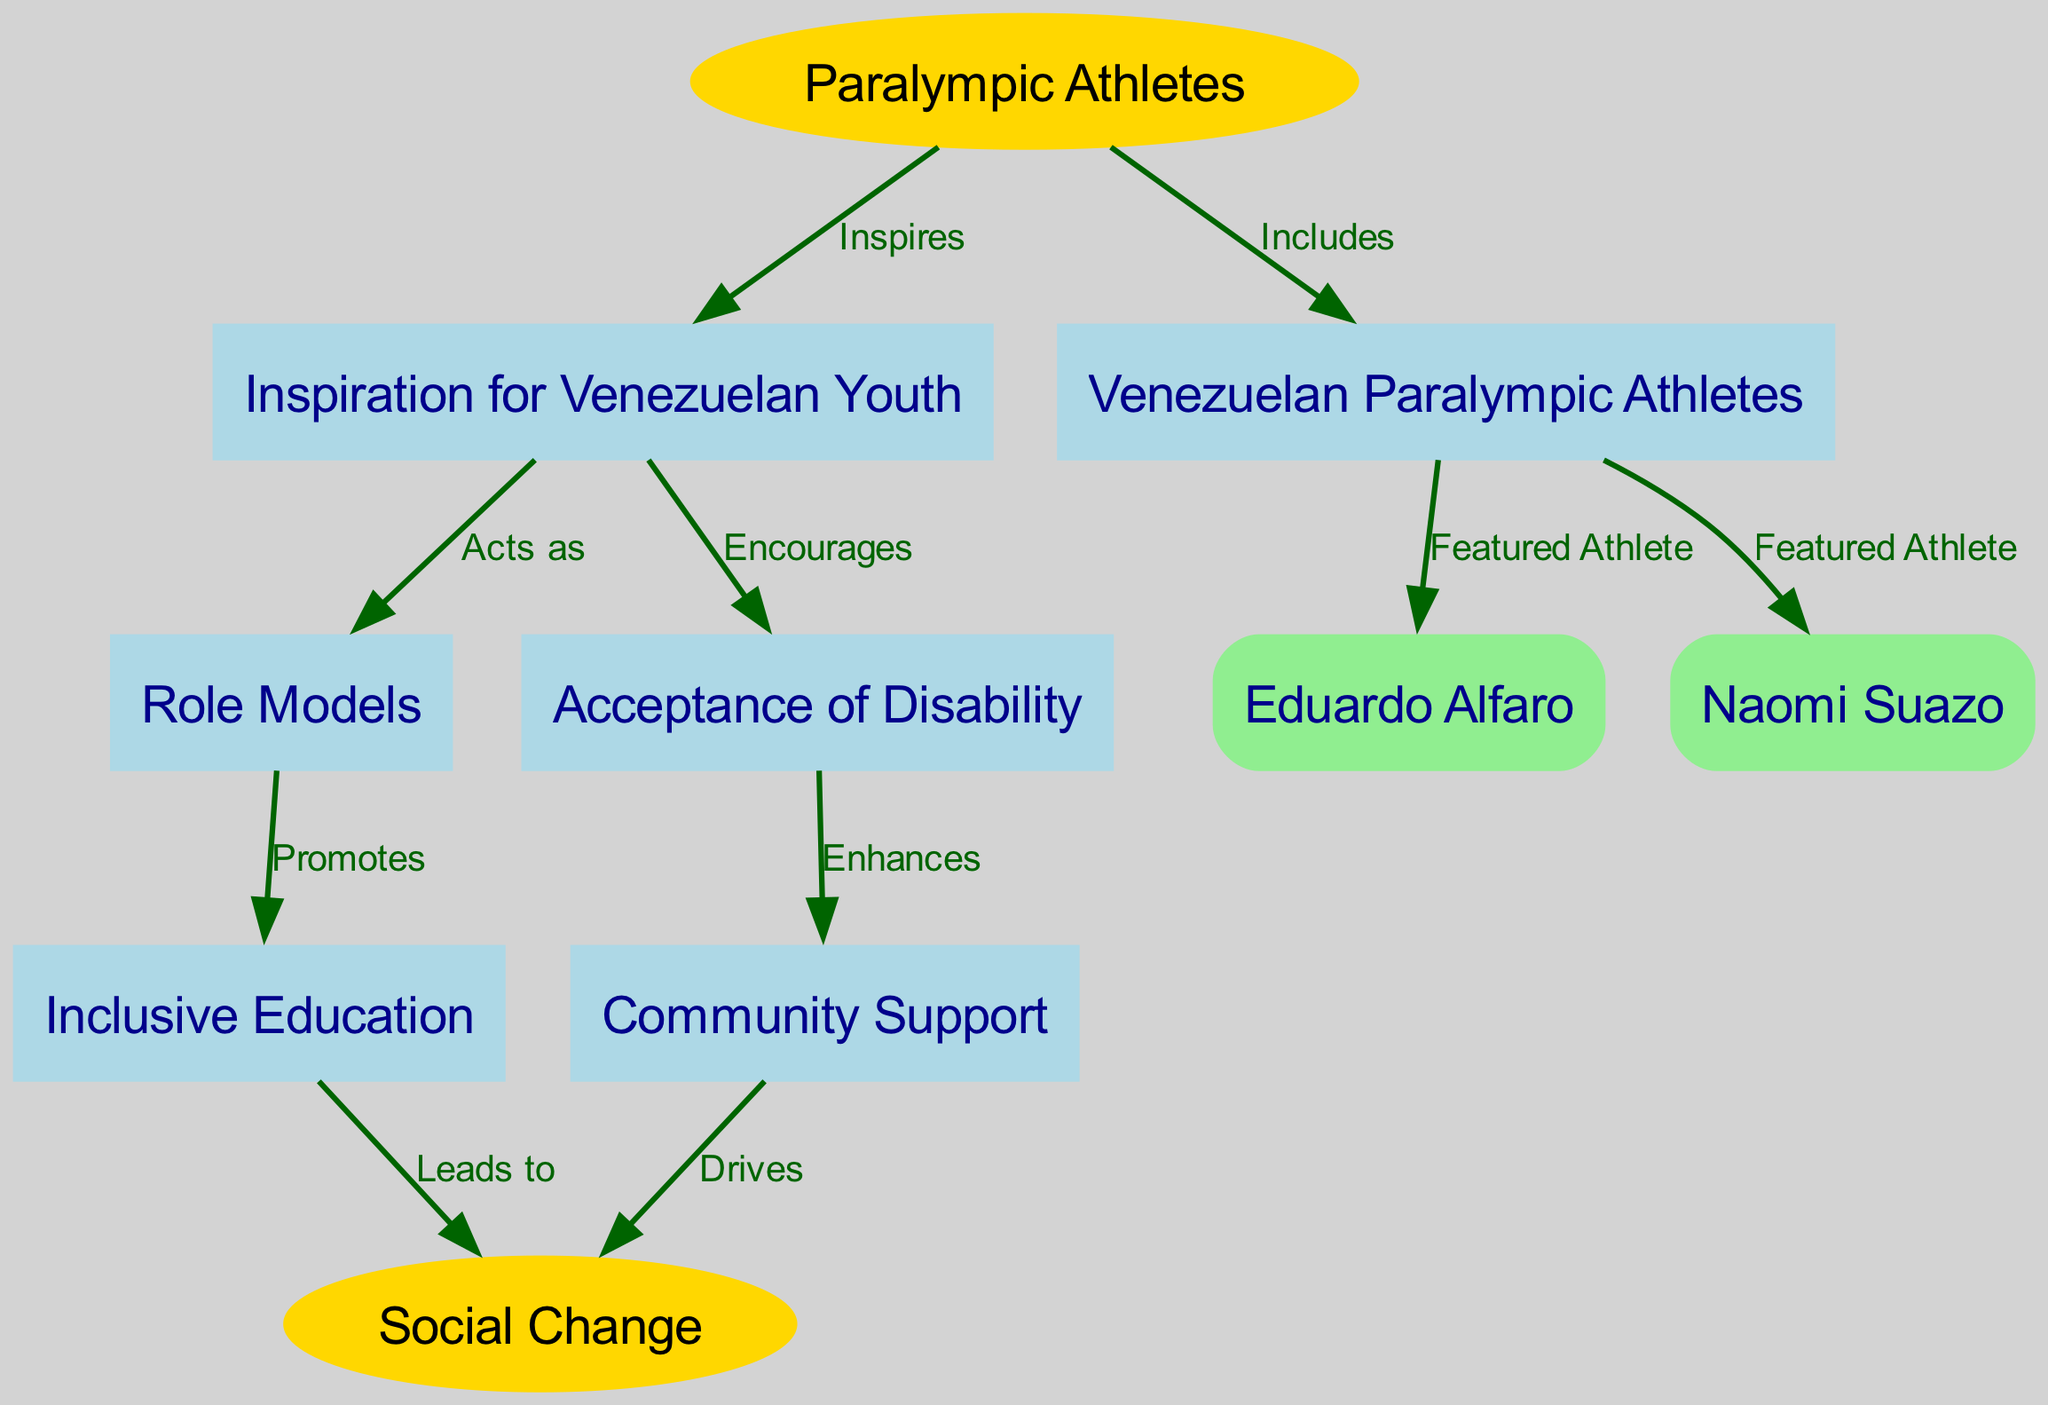What is the main role of Paralympic athletes in the diagram? The main role of Paralympic athletes is to inspire Venezuelan youth, as depicted in the edge labeled "Inspires" that connects "Paralympic Athletes" to "Inspiration for Venezuelan Youth".
Answer: Inspires How many featured athletes are identified in the diagram? The diagram shows two featured athletes: Eduardo Alfaro and Naomi Suazo, directly connected to "Venezuelan Paralympic Athletes".
Answer: Two What does youth inspiration encourage according to the diagram? The "Youth Inspiration" node connects to "Accepting Disability" with an edge labeled "Encourages", which indicates that it encourages acceptance among youth.
Answer: Accepting Disability Which concept leads to social change? The diagram indicates that "Inclusive Education" connects to "Social Change" with an edge labeled "Leads to", demonstrating that this is the pathway for achieving social change.
Answer: Inclusive Education What enhances community support in the diagram? "Accepting Disability" promotes "Community Support" with an edge labeled "Enhances", illustrating that acceptance leads to better support within communities.
Answer: Accepting Disability What is the connection between role models and inclusive education? The relationship is shown in the edge labeled "Promotes", which connects "Role Models" to "Inclusive Education", indicating that role models aid in advancing inclusive education practices.
Answer: Promotes What drives social change according to the diagram? The diagram shows that "Community Support" drives "Social Change", connecting the two concepts with an edge labeled "Drives".
Answer: Community Support What type of education is promoted by role models in the context of Paralympic athletes? Role models promote "Inclusive Education", as stated in the edge from "Role Models" to "Inclusive Education" labeled "Promotes".
Answer: Inclusive Education How do Venezuelan Paralympic athletes relate to youth inspiration? The "Venezuelan Paralympic Athletes" node is a subset of "Paralympic Athletes" and contributes to "Youth Inspiration" through the edge labeled "Includes", indicating their impact on inspiring youth.
Answer: Includes 